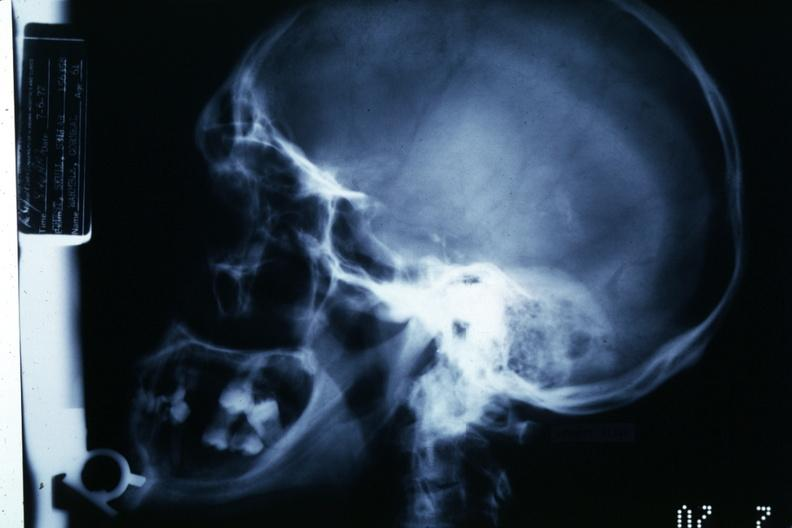what is present?
Answer the question using a single word or phrase. Bone, calvarium 